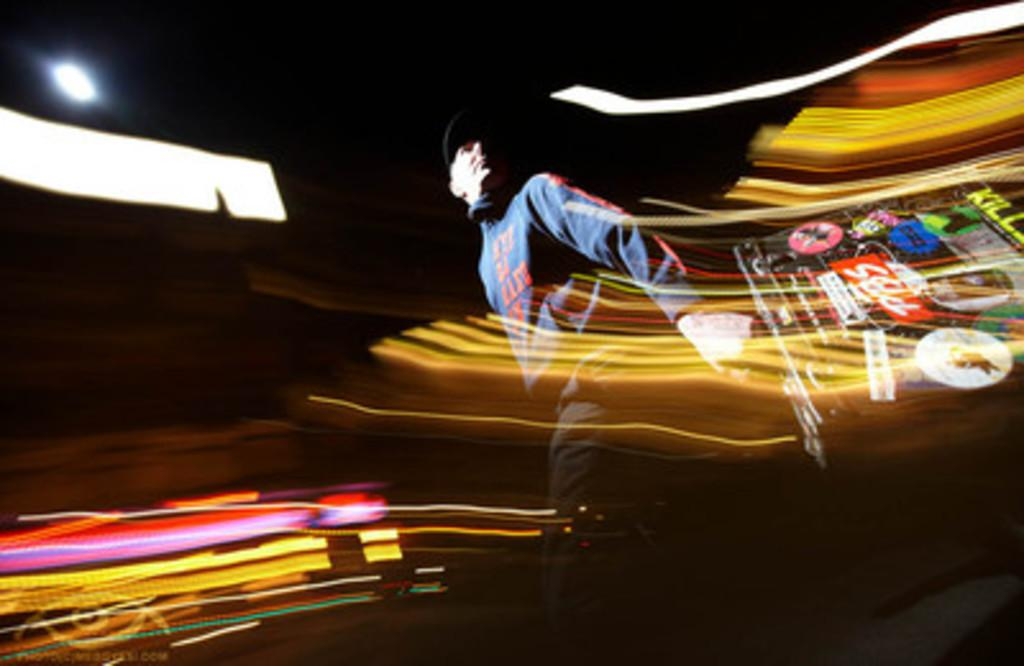What is the overall quality of the image? The image is blurry. Can you identify any people in the image? Yes, there is a man in the image. What other elements are present in the image? There are colorful lights in the image. How would you describe the lighting conditions in the image? The background of the image is dark. What type of feather can be seen falling in the image? There is no feather present in the image. How does the man react to the falling feather in the image? There is no feather or reaction to it in the image, as there is no feather present. 